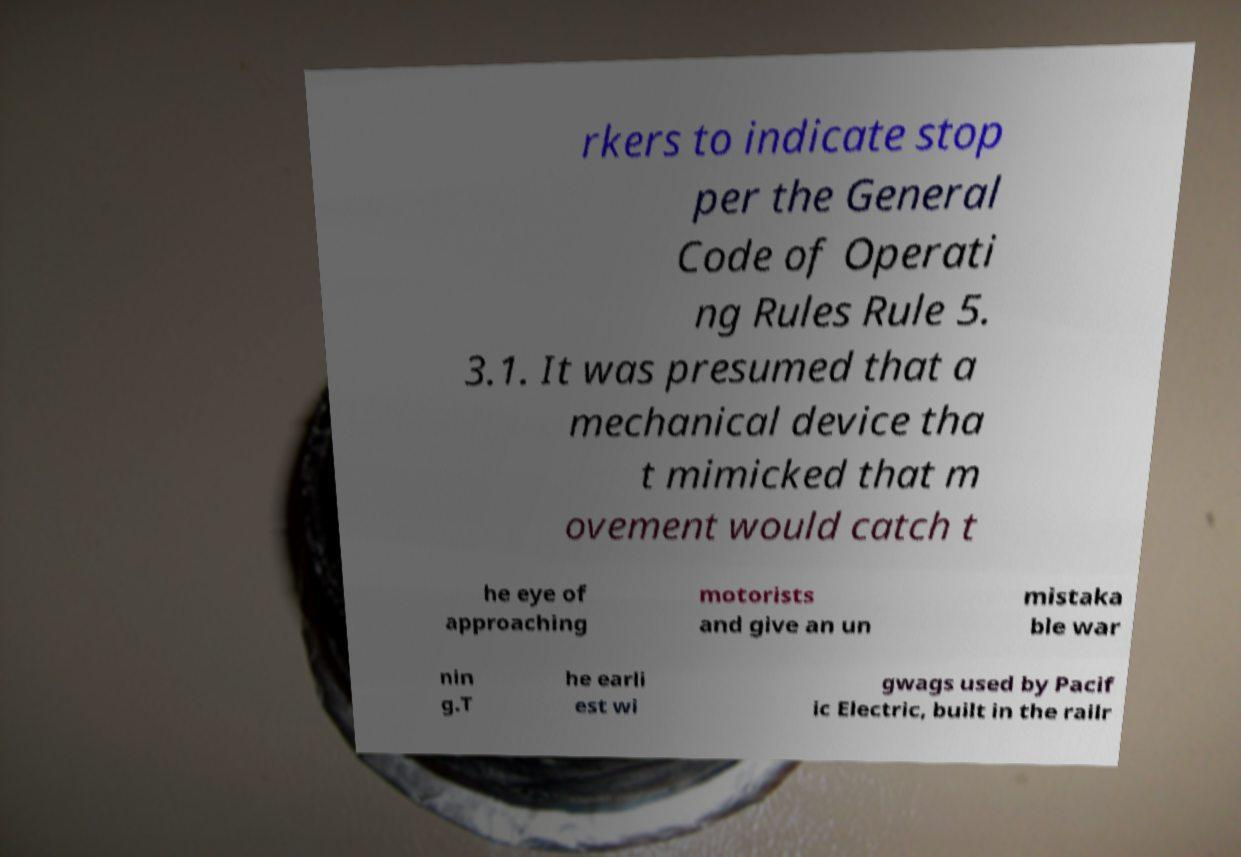Please identify and transcribe the text found in this image. rkers to indicate stop per the General Code of Operati ng Rules Rule 5. 3.1. It was presumed that a mechanical device tha t mimicked that m ovement would catch t he eye of approaching motorists and give an un mistaka ble war nin g.T he earli est wi gwags used by Pacif ic Electric, built in the railr 